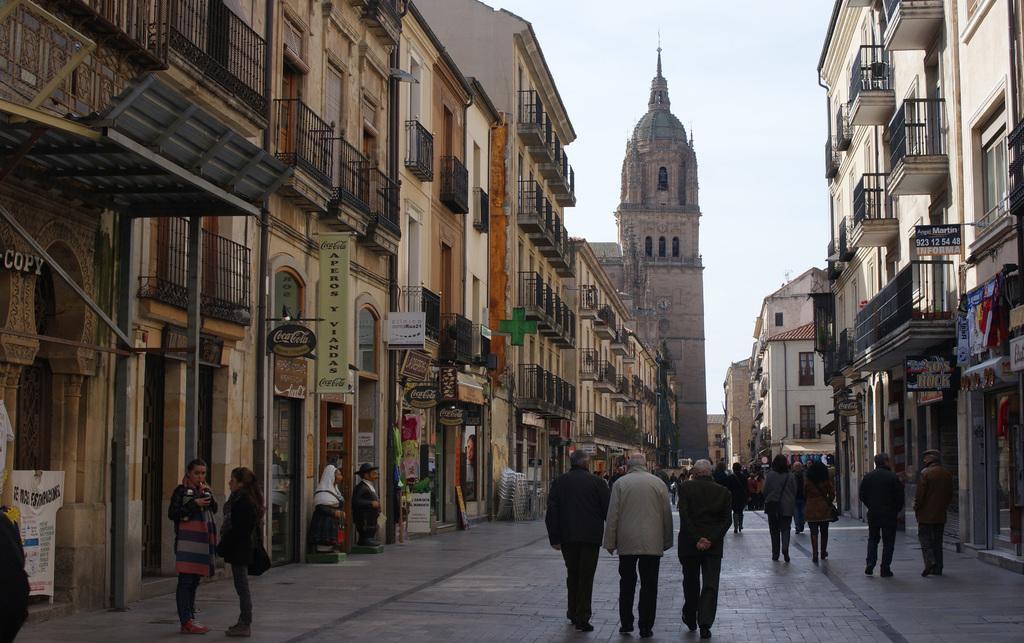Please provide a concise description of this image. In this picture we can observe some people walking in this path. On either sides of this path there are buildings. In the background there is a sky. 